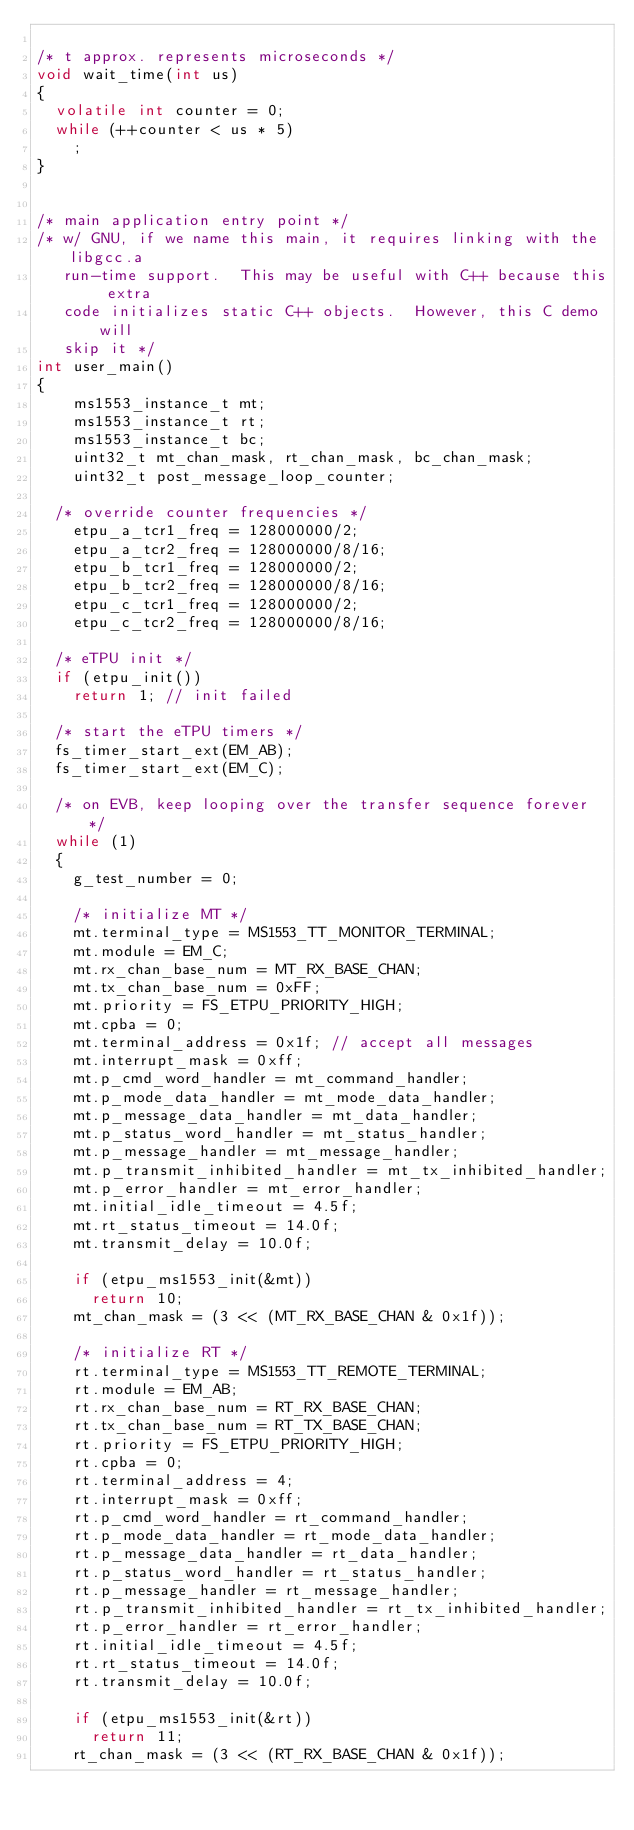Convert code to text. <code><loc_0><loc_0><loc_500><loc_500><_C_>
/* t approx. represents microseconds */
void wait_time(int us)
{
	volatile int counter = 0;
	while (++counter < us * 5)
		;
}


/* main application entry point */
/* w/ GNU, if we name this main, it requires linking with the libgcc.a
   run-time support.  This may be useful with C++ because this extra
   code initializes static C++ objects.  However, this C demo will
   skip it */
int user_main()
{
    ms1553_instance_t mt;
    ms1553_instance_t rt;
    ms1553_instance_t bc;
    uint32_t mt_chan_mask, rt_chan_mask, bc_chan_mask;
    uint32_t post_message_loop_counter;
    
	/* override counter frequencies */
    etpu_a_tcr1_freq = 128000000/2;
    etpu_a_tcr2_freq = 128000000/8/16;
    etpu_b_tcr1_freq = 128000000/2;
    etpu_b_tcr2_freq = 128000000/8/16;
    etpu_c_tcr1_freq = 128000000/2;
    etpu_c_tcr2_freq = 128000000/8/16;

	/* eTPU init */
	if (etpu_init())
		return 1; // init failed

	/* start the eTPU timers */
	fs_timer_start_ext(EM_AB);
	fs_timer_start_ext(EM_C);

	/* on EVB, keep looping over the transfer sequence forever */
	while (1)
	{
		g_test_number = 0;

		/* initialize MT */
		mt.terminal_type = MS1553_TT_MONITOR_TERMINAL;
		mt.module = EM_C;
		mt.rx_chan_base_num = MT_RX_BASE_CHAN;
		mt.tx_chan_base_num = 0xFF;
		mt.priority = FS_ETPU_PRIORITY_HIGH;
		mt.cpba = 0;
		mt.terminal_address = 0x1f; // accept all messages
		mt.interrupt_mask = 0xff;
		mt.p_cmd_word_handler = mt_command_handler;
		mt.p_mode_data_handler = mt_mode_data_handler;
		mt.p_message_data_handler = mt_data_handler;
		mt.p_status_word_handler = mt_status_handler;
		mt.p_message_handler = mt_message_handler;
		mt.p_transmit_inhibited_handler = mt_tx_inhibited_handler;
		mt.p_error_handler = mt_error_handler;
		mt.initial_idle_timeout = 4.5f;
		mt.rt_status_timeout = 14.0f;
		mt.transmit_delay = 10.0f;

		if (etpu_ms1553_init(&mt))
			return 10;
		mt_chan_mask = (3 << (MT_RX_BASE_CHAN & 0x1f));

		/* initialize RT */
		rt.terminal_type = MS1553_TT_REMOTE_TERMINAL;
		rt.module = EM_AB;
		rt.rx_chan_base_num = RT_RX_BASE_CHAN;
		rt.tx_chan_base_num = RT_TX_BASE_CHAN;
		rt.priority = FS_ETPU_PRIORITY_HIGH;
		rt.cpba = 0;
		rt.terminal_address = 4;
		rt.interrupt_mask = 0xff;
		rt.p_cmd_word_handler = rt_command_handler;
		rt.p_mode_data_handler = rt_mode_data_handler;
		rt.p_message_data_handler = rt_data_handler;
		rt.p_status_word_handler = rt_status_handler;
		rt.p_message_handler = rt_message_handler;
		rt.p_transmit_inhibited_handler = rt_tx_inhibited_handler;
		rt.p_error_handler = rt_error_handler;
		rt.initial_idle_timeout = 4.5f;
		rt.rt_status_timeout = 14.0f;
		rt.transmit_delay = 10.0f;

		if (etpu_ms1553_init(&rt))
			return 11;
		rt_chan_mask = (3 << (RT_RX_BASE_CHAN & 0x1f));
</code> 